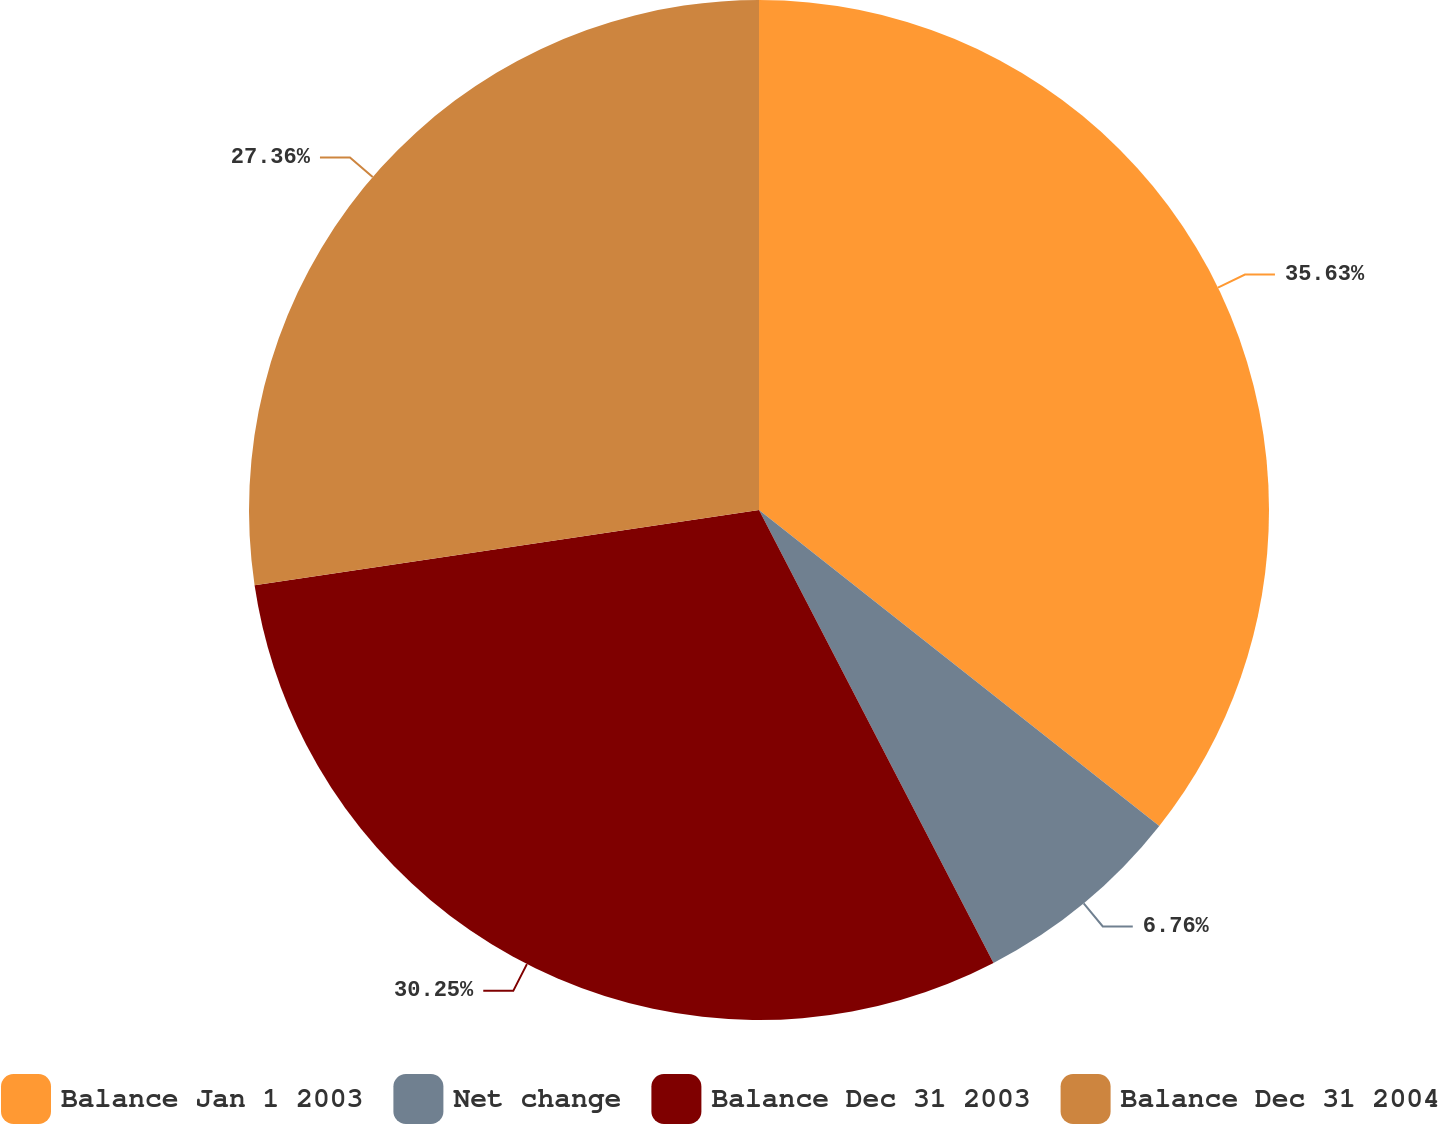Convert chart. <chart><loc_0><loc_0><loc_500><loc_500><pie_chart><fcel>Balance Jan 1 2003<fcel>Net change<fcel>Balance Dec 31 2003<fcel>Balance Dec 31 2004<nl><fcel>35.64%<fcel>6.76%<fcel>30.25%<fcel>27.36%<nl></chart> 